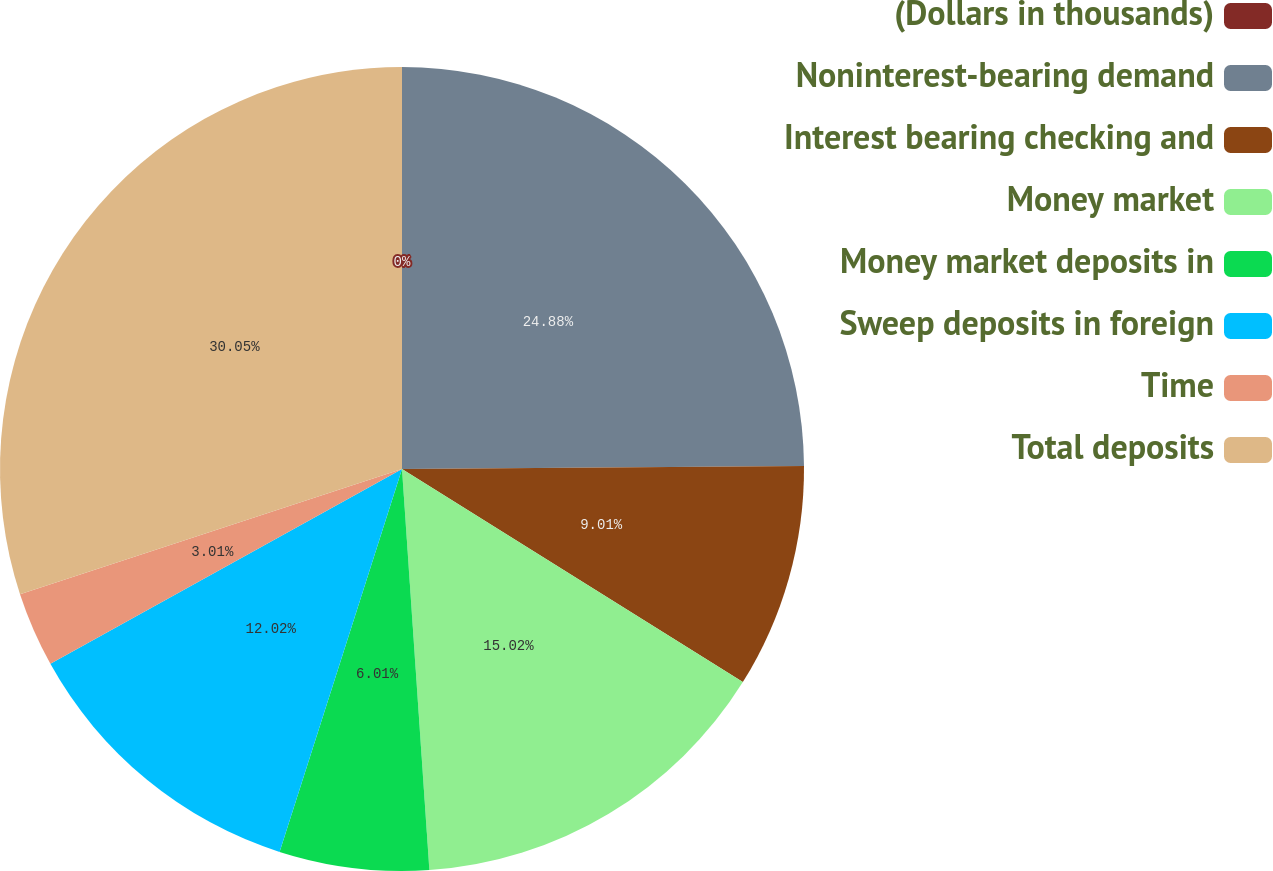Convert chart. <chart><loc_0><loc_0><loc_500><loc_500><pie_chart><fcel>(Dollars in thousands)<fcel>Noninterest-bearing demand<fcel>Interest bearing checking and<fcel>Money market<fcel>Money market deposits in<fcel>Sweep deposits in foreign<fcel>Time<fcel>Total deposits<nl><fcel>0.0%<fcel>24.88%<fcel>9.01%<fcel>15.02%<fcel>6.01%<fcel>12.02%<fcel>3.01%<fcel>30.04%<nl></chart> 